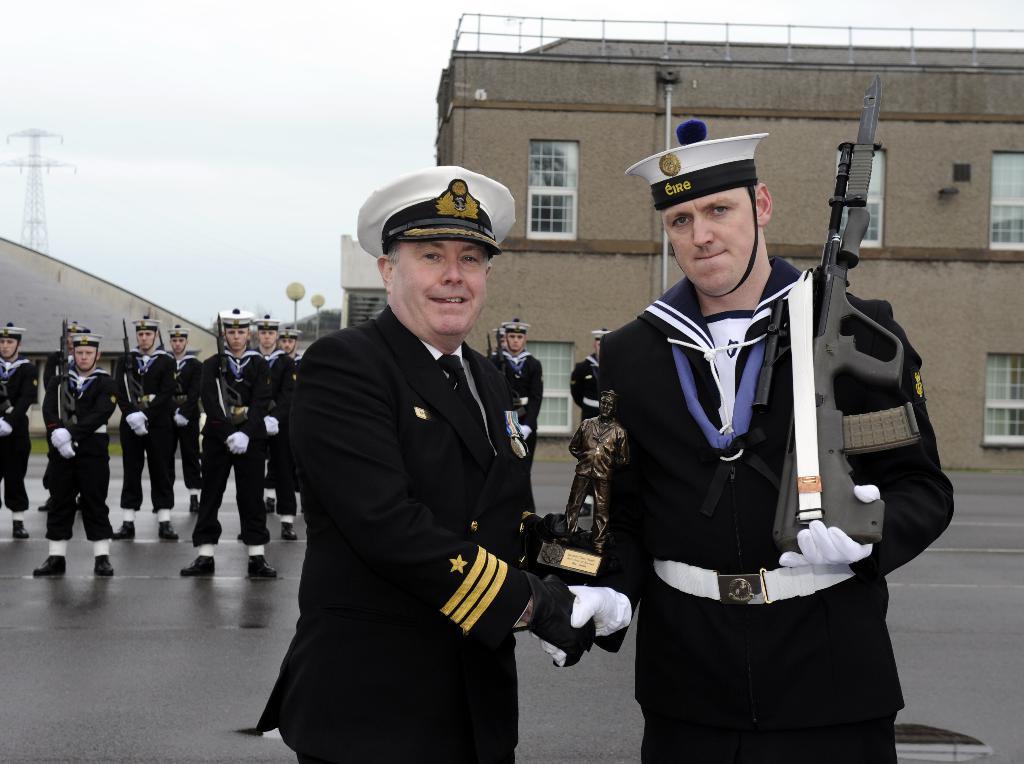In one or two sentences, can you explain what this image depicts? This image is clicked on the road. There are people standing on the road. In the foreground there are two men standing. They are holding a sculpture in their hand. The man to the right is holding a gun in his hand. In the background there are buildings and street light poles. At the top there is the sky. 